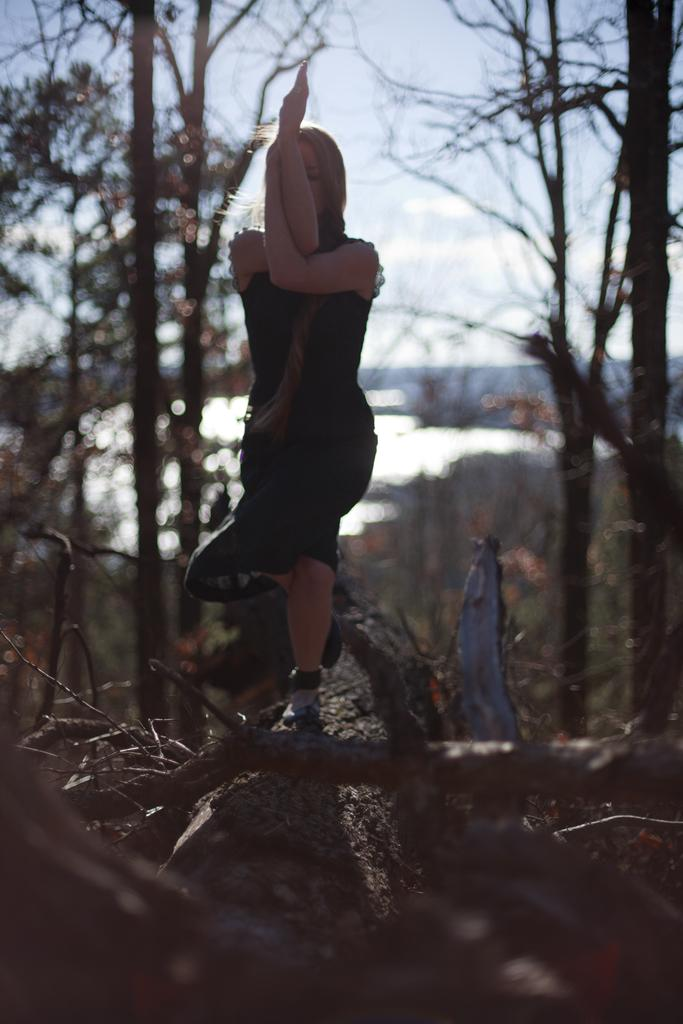What is the main subject of the image? There is a woman in the image. What is the woman doing in the image? The woman is standing. What is the woman wearing in the image? The woman is wearing a black dress. What can be seen in the background of the image? There are trees and water visible in the background. How would you describe the sky in the image? The sky is a combination of white and blue colors. Can you see any steam coming from the oatmeal in the image? There is no oatmeal or steam present in the image. What type of cow can be seen grazing in the background of the image? There is no cow present in the image; only trees and water are visible in the background. 